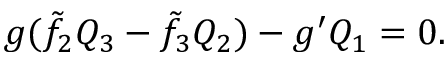Convert formula to latex. <formula><loc_0><loc_0><loc_500><loc_500>g ( \tilde { f } _ { 2 } Q _ { 3 } - \tilde { f } _ { 3 } Q _ { 2 } ) - g ^ { \prime } Q _ { 1 } = 0 .</formula> 